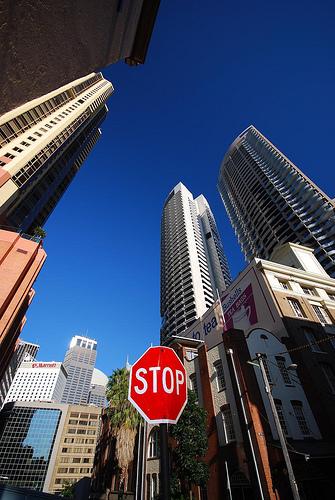What type of sign is this?
Be succinct. Stop. What color is the sky?
Quick response, please. Blue. What is the shortest object in the photo?
Answer briefly. Stop sign. 